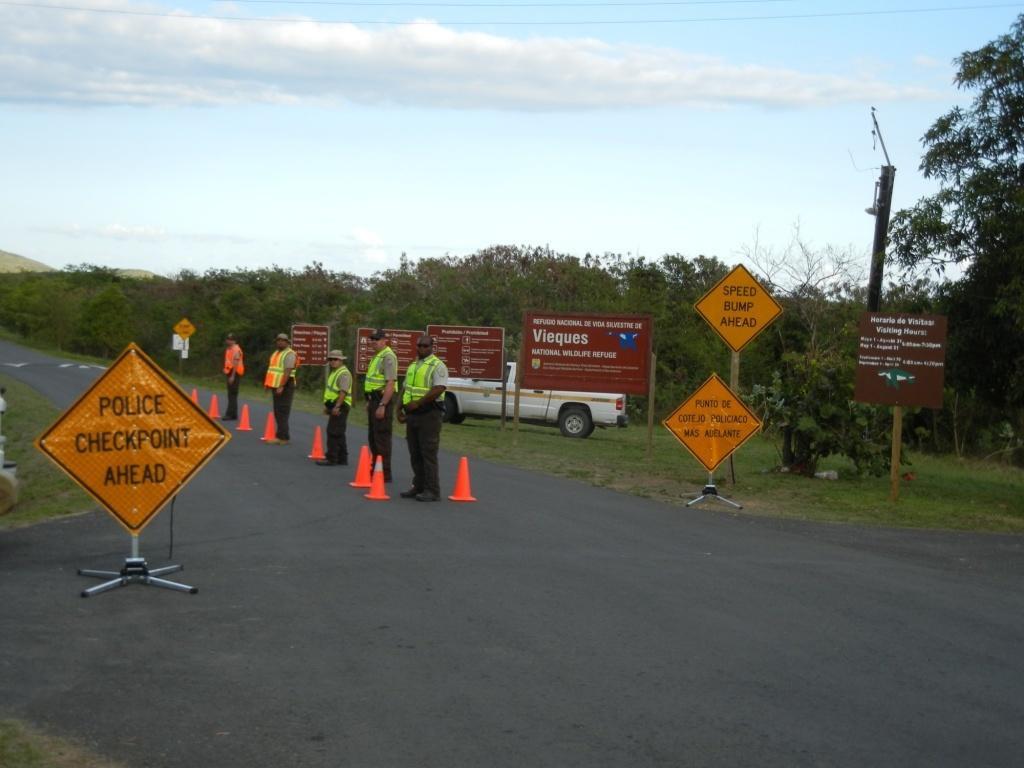What kind of checkpoint is ahead?
Your answer should be compact. Police. What is ahead?
Your answer should be compact. Police checkpoint. 